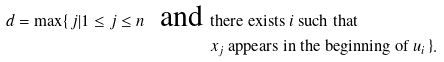<formula> <loc_0><loc_0><loc_500><loc_500>d = \max \{ \, j | 1 \leq j \leq n \ \text { and } & \text {there exists $i$ such that} \\ & \text {$x_{j}$ appears in the beginning of $u_{i}$} \, \} .</formula> 